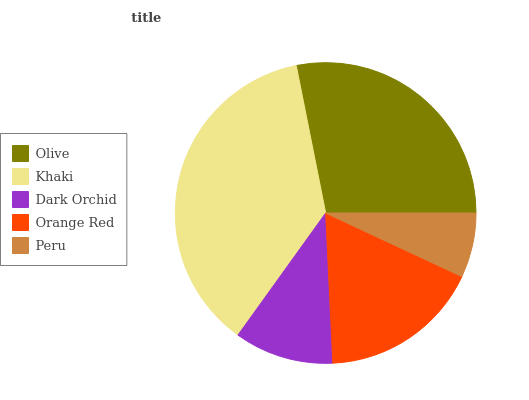Is Peru the minimum?
Answer yes or no. Yes. Is Khaki the maximum?
Answer yes or no. Yes. Is Dark Orchid the minimum?
Answer yes or no. No. Is Dark Orchid the maximum?
Answer yes or no. No. Is Khaki greater than Dark Orchid?
Answer yes or no. Yes. Is Dark Orchid less than Khaki?
Answer yes or no. Yes. Is Dark Orchid greater than Khaki?
Answer yes or no. No. Is Khaki less than Dark Orchid?
Answer yes or no. No. Is Orange Red the high median?
Answer yes or no. Yes. Is Orange Red the low median?
Answer yes or no. Yes. Is Peru the high median?
Answer yes or no. No. Is Khaki the low median?
Answer yes or no. No. 